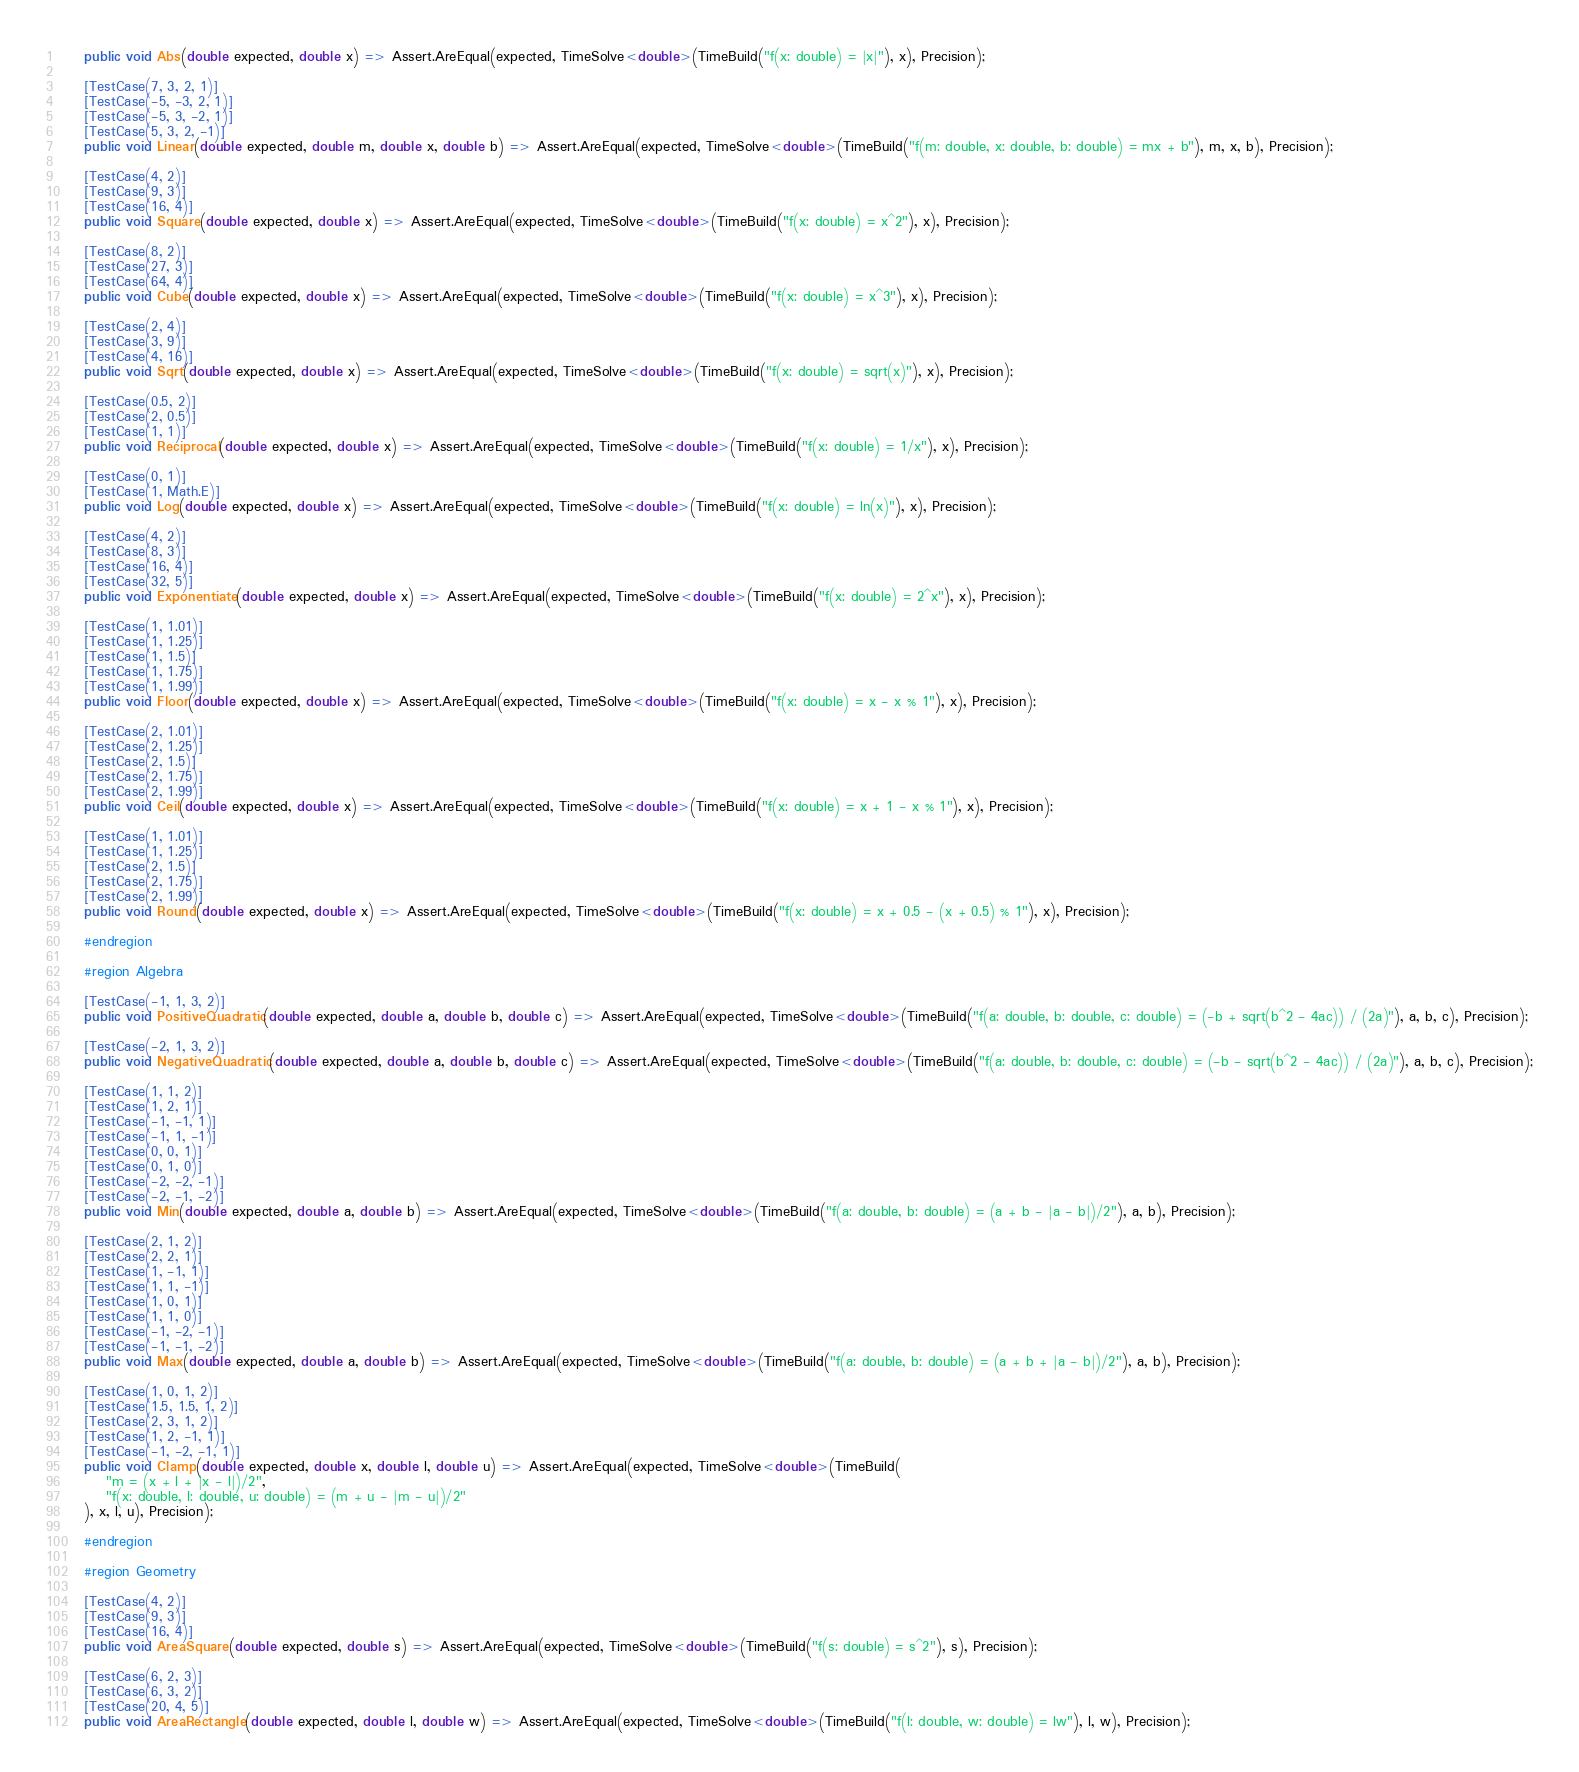<code> <loc_0><loc_0><loc_500><loc_500><_C#_>	public void Abs(double expected, double x) => Assert.AreEqual(expected, TimeSolve<double>(TimeBuild("f(x: double) = |x|"), x), Precision);

	[TestCase(7, 3, 2, 1)]
	[TestCase(-5, -3, 2, 1)]
	[TestCase(-5, 3, -2, 1)]
	[TestCase(5, 3, 2, -1)]
	public void Linear(double expected, double m, double x, double b) => Assert.AreEqual(expected, TimeSolve<double>(TimeBuild("f(m: double, x: double, b: double) = mx + b"), m, x, b), Precision);

	[TestCase(4, 2)]
	[TestCase(9, 3)]
	[TestCase(16, 4)]
	public void Square(double expected, double x) => Assert.AreEqual(expected, TimeSolve<double>(TimeBuild("f(x: double) = x^2"), x), Precision);

	[TestCase(8, 2)]
	[TestCase(27, 3)]
	[TestCase(64, 4)]
	public void Cube(double expected, double x) => Assert.AreEqual(expected, TimeSolve<double>(TimeBuild("f(x: double) = x^3"), x), Precision);

	[TestCase(2, 4)]
	[TestCase(3, 9)]
	[TestCase(4, 16)]
	public void Sqrt(double expected, double x) => Assert.AreEqual(expected, TimeSolve<double>(TimeBuild("f(x: double) = sqrt(x)"), x), Precision);

	[TestCase(0.5, 2)]
	[TestCase(2, 0.5)]
	[TestCase(1, 1)]
	public void Reciprocal(double expected, double x) => Assert.AreEqual(expected, TimeSolve<double>(TimeBuild("f(x: double) = 1/x"), x), Precision);

	[TestCase(0, 1)]
	[TestCase(1, Math.E)]
	public void Log(double expected, double x) => Assert.AreEqual(expected, TimeSolve<double>(TimeBuild("f(x: double) = ln(x)"), x), Precision);

	[TestCase(4, 2)]
	[TestCase(8, 3)]
	[TestCase(16, 4)]
	[TestCase(32, 5)]
	public void Exponentiate(double expected, double x) => Assert.AreEqual(expected, TimeSolve<double>(TimeBuild("f(x: double) = 2^x"), x), Precision);

	[TestCase(1, 1.01)]
	[TestCase(1, 1.25)]
	[TestCase(1, 1.5)]
	[TestCase(1, 1.75)]
	[TestCase(1, 1.99)]
	public void Floor(double expected, double x) => Assert.AreEqual(expected, TimeSolve<double>(TimeBuild("f(x: double) = x - x % 1"), x), Precision);

	[TestCase(2, 1.01)]
	[TestCase(2, 1.25)]
	[TestCase(2, 1.5)]
	[TestCase(2, 1.75)]
	[TestCase(2, 1.99)]
	public void Ceil(double expected, double x) => Assert.AreEqual(expected, TimeSolve<double>(TimeBuild("f(x: double) = x + 1 - x % 1"), x), Precision);

	[TestCase(1, 1.01)]
	[TestCase(1, 1.25)]
	[TestCase(2, 1.5)]
	[TestCase(2, 1.75)]
	[TestCase(2, 1.99)]
	public void Round(double expected, double x) => Assert.AreEqual(expected, TimeSolve<double>(TimeBuild("f(x: double) = x + 0.5 - (x + 0.5) % 1"), x), Precision);

	#endregion

	#region Algebra

	[TestCase(-1, 1, 3, 2)]
	public void PositiveQuadratic(double expected, double a, double b, double c) => Assert.AreEqual(expected, TimeSolve<double>(TimeBuild("f(a: double, b: double, c: double) = (-b + sqrt(b^2 - 4ac)) / (2a)"), a, b, c), Precision);

	[TestCase(-2, 1, 3, 2)]
	public void NegativeQuadratic(double expected, double a, double b, double c) => Assert.AreEqual(expected, TimeSolve<double>(TimeBuild("f(a: double, b: double, c: double) = (-b - sqrt(b^2 - 4ac)) / (2a)"), a, b, c), Precision);

	[TestCase(1, 1, 2)]
	[TestCase(1, 2, 1)]
	[TestCase(-1, -1, 1)]
	[TestCase(-1, 1, -1)]
	[TestCase(0, 0, 1)]
	[TestCase(0, 1, 0)]
	[TestCase(-2, -2, -1)]
	[TestCase(-2, -1, -2)]
	public void Min(double expected, double a, double b) => Assert.AreEqual(expected, TimeSolve<double>(TimeBuild("f(a: double, b: double) = (a + b - |a - b|)/2"), a, b), Precision);

	[TestCase(2, 1, 2)]
	[TestCase(2, 2, 1)]
	[TestCase(1, -1, 1)]
	[TestCase(1, 1, -1)]
	[TestCase(1, 0, 1)]
	[TestCase(1, 1, 0)]
	[TestCase(-1, -2, -1)]
	[TestCase(-1, -1, -2)]
	public void Max(double expected, double a, double b) => Assert.AreEqual(expected, TimeSolve<double>(TimeBuild("f(a: double, b: double) = (a + b + |a - b|)/2"), a, b), Precision);

	[TestCase(1, 0, 1, 2)]
	[TestCase(1.5, 1.5, 1, 2)]
	[TestCase(2, 3, 1, 2)]
	[TestCase(1, 2, -1, 1)]
	[TestCase(-1, -2, -1, 1)]
	public void Clamp(double expected, double x, double l, double u) => Assert.AreEqual(expected, TimeSolve<double>(TimeBuild(
		"m = (x + l + |x - l|)/2",
		"f(x: double, l: double, u: double) = (m + u - |m - u|)/2"
	), x, l, u), Precision);

	#endregion

	#region Geometry

	[TestCase(4, 2)]
	[TestCase(9, 3)]
	[TestCase(16, 4)]
	public void AreaSquare(double expected, double s) => Assert.AreEqual(expected, TimeSolve<double>(TimeBuild("f(s: double) = s^2"), s), Precision);

	[TestCase(6, 2, 3)]
	[TestCase(6, 3, 2)]
	[TestCase(20, 4, 5)]
	public void AreaRectangle(double expected, double l, double w) => Assert.AreEqual(expected, TimeSolve<double>(TimeBuild("f(l: double, w: double) = lw"), l, w), Precision);
</code> 